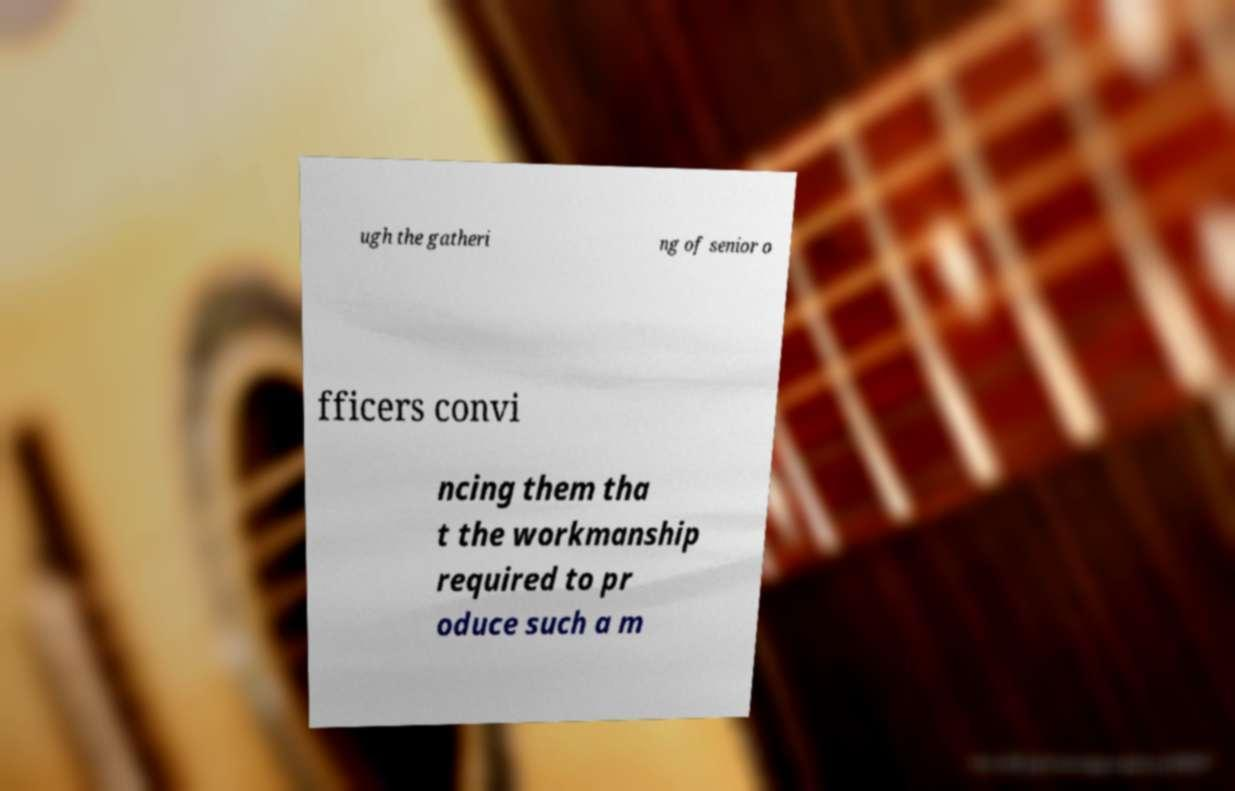Please identify and transcribe the text found in this image. ugh the gatheri ng of senior o fficers convi ncing them tha t the workmanship required to pr oduce such a m 